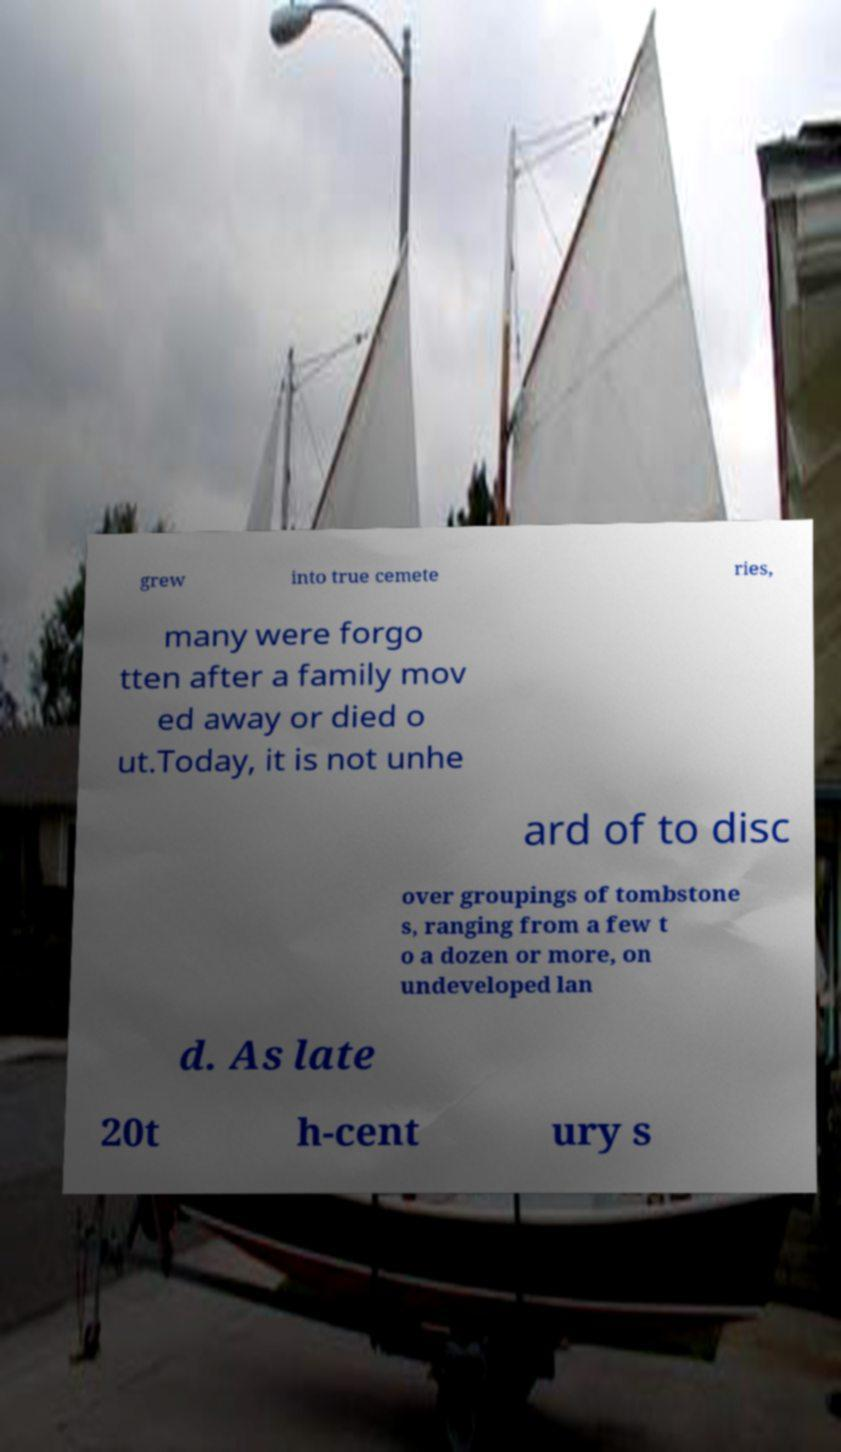What messages or text are displayed in this image? I need them in a readable, typed format. grew into true cemete ries, many were forgo tten after a family mov ed away or died o ut.Today, it is not unhe ard of to disc over groupings of tombstone s, ranging from a few t o a dozen or more, on undeveloped lan d. As late 20t h-cent ury s 